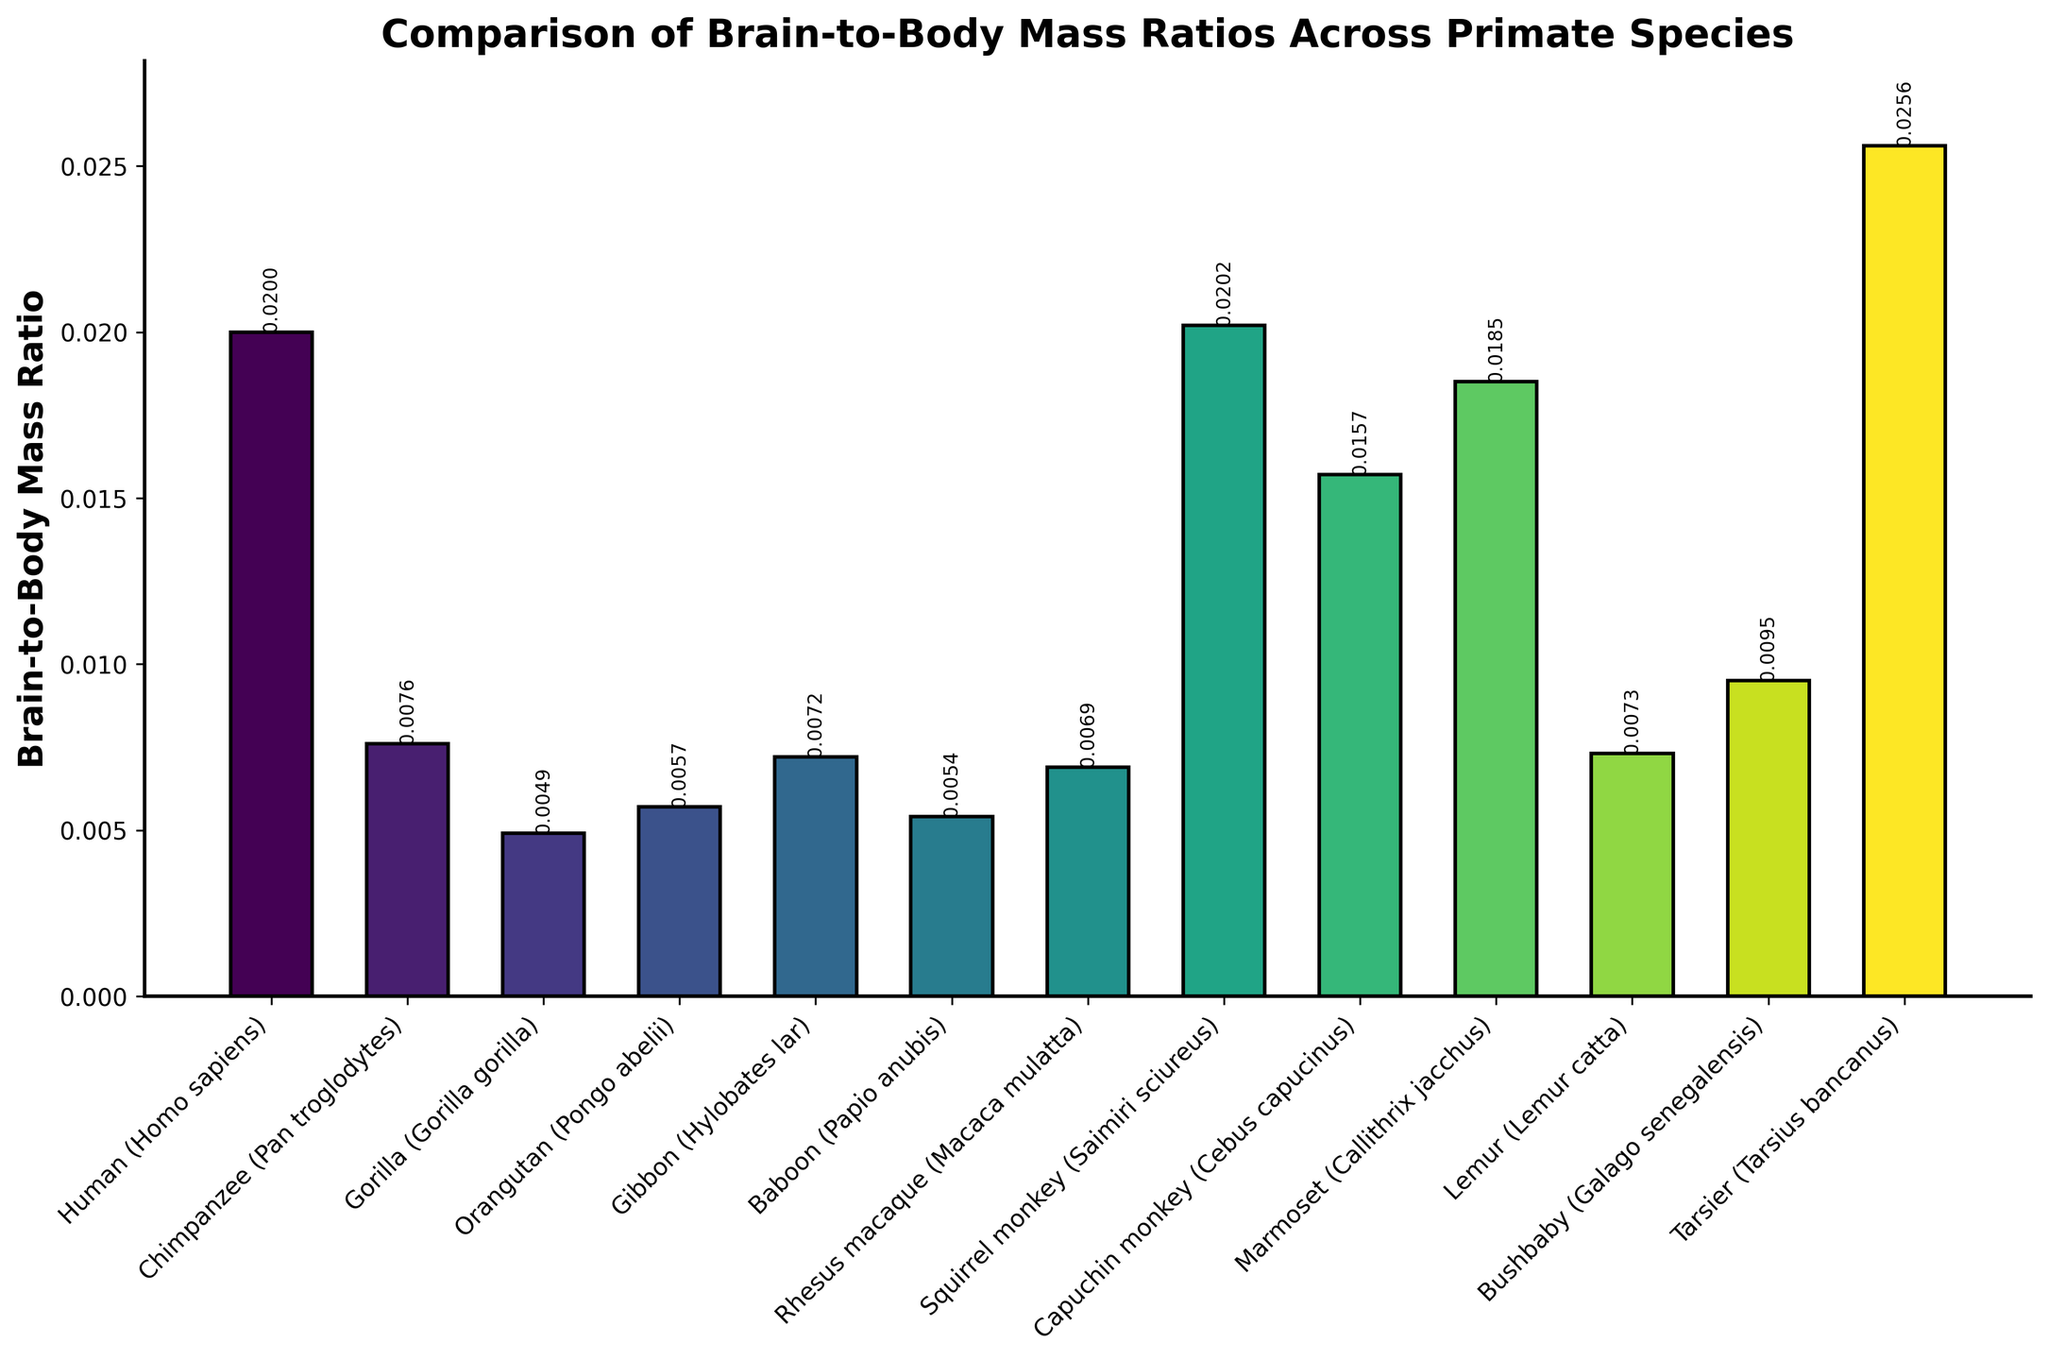Can you identify which species has the highest brain-to-body mass ratio? The highest bar corresponds to the Tarsier (Tarsius bancanus), with a brain-to-body mass ratio of 0.0256.
Answer: Tarsier (Tarsius bancanus) Which species has a brain-to-body mass ratio closest to humans? The human species has a ratio of 0.02. The species with a brain-to-body mass ratio closest to this is the Marmoset (Callithrix jacchus) with a ratio of 0.0185.
Answer: Marmoset (Callithrix jacchus) What's the difference in brain-to-body mass ratio between the species with the highest and lowest ratios? The highest ratio is for the Tarsier (0.0256) and the lowest is for the Gorilla (0.0049). The difference is 0.0256 - 0.0049 = 0.0207.
Answer: 0.0207 Compare the brain-to-body mass ratio of Humans and Chimpanzees. Which species has a higher ratio and by how much? Humans have a ratio of 0.02, while Chimpanzees have 0.0076. The difference is 0.02 - 0.0076 = 0.0124.
Answer: Humans, by 0.0124 Among the given species, how many have a brain-to-body mass ratio greater than 0.01? The species with ratios greater than 0.01 are Humans (0.02), Squirrel monkey (0.0202), Capuchin monkey (0.0157), Marmoset (0.0185), Bushbaby (0.0095 rounding up to 0.010), and Tarsier (0.0256). Counting these, there are 5 species.
Answer: 5 Which species has a brain-to-body mass ratio closest to 0.007? Gibbon (0.0072) and Lemur (0.0073) are close to 0.007, with Lemur being the nearest.
Answer: Lemur (Lemur catta) Compare the visual height of the bars for the Squirrel monkey and the Capuchin monkey. Which bar is taller and what might this indicate about their brain-to-body mass ratios? The bar for the Squirrel monkey is taller than the Capuchin monkey, indicating that the brain-to-body mass ratio for the Squirrel monkey (0.0202) is higher than that of the Capuchin monkey (0.0157).
Answer: Squirrel monkey (Saimiri sciureus) Of all the species listed, how many have a brain-to-body mass ratio less than 0.006? The species with ratios less than 0.006 include Gorilla (0.0049), Orangutan (0.0057), and Baboon (0.0054). There are 3 species in this range.
Answer: 3 Which species has the second-highest brain-to-body mass ratio? The second-highest brain-to-body mass ratio after the Tarsier (0.0256) is the Squirrel monkey (Saimiri sciureus) with a ratio of 0.0202.
Answer: Squirrel monkey (Saimiri sciureus) 